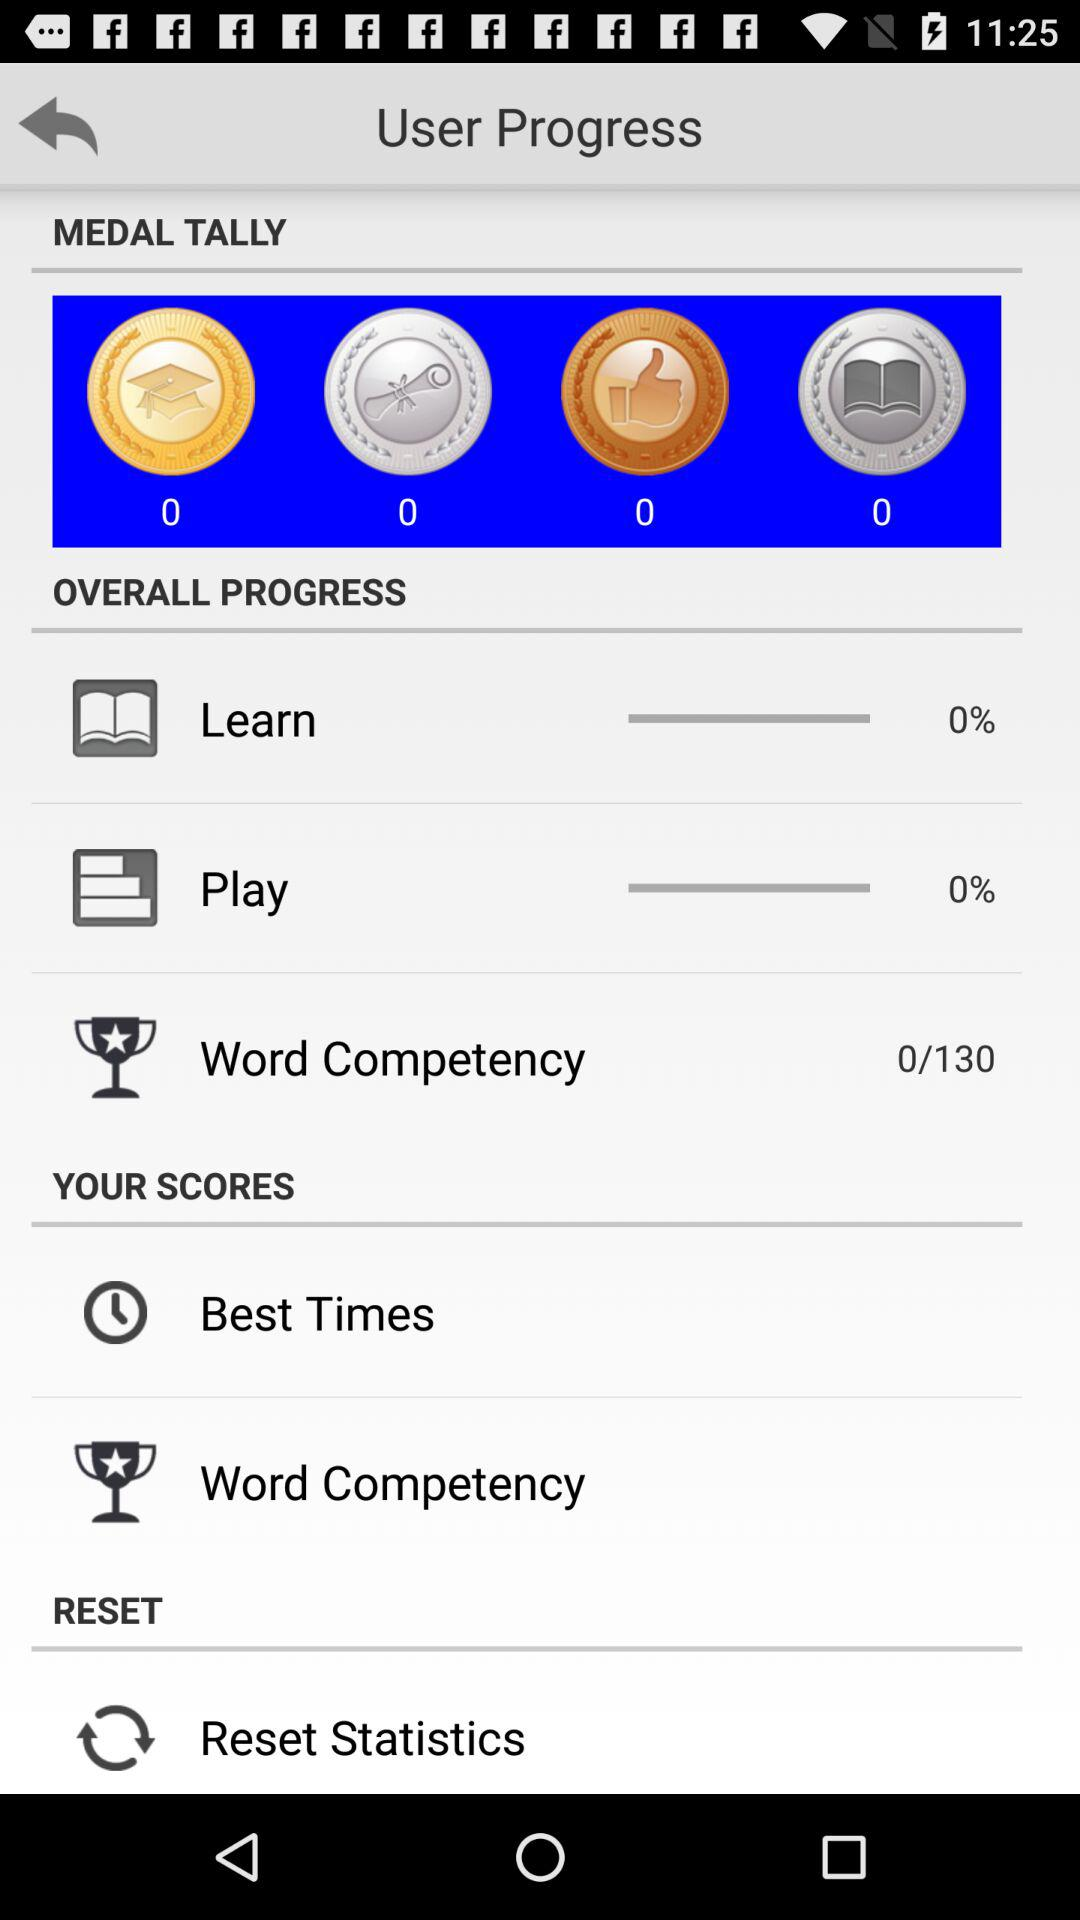What is the report of the play?
When the provided information is insufficient, respond with <no answer>. <no answer> 